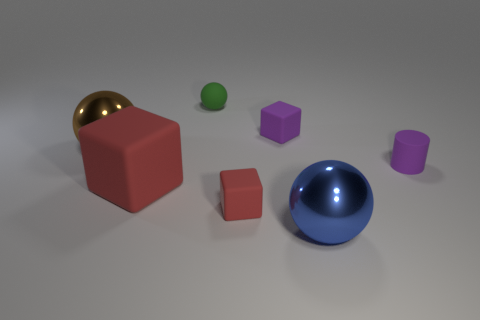Add 1 small cyan metal cubes. How many objects exist? 8 Subtract all spheres. How many objects are left? 4 Subtract all metallic balls. Subtract all large rubber cubes. How many objects are left? 4 Add 7 small green rubber balls. How many small green rubber balls are left? 8 Add 3 red blocks. How many red blocks exist? 5 Subtract 1 brown spheres. How many objects are left? 6 